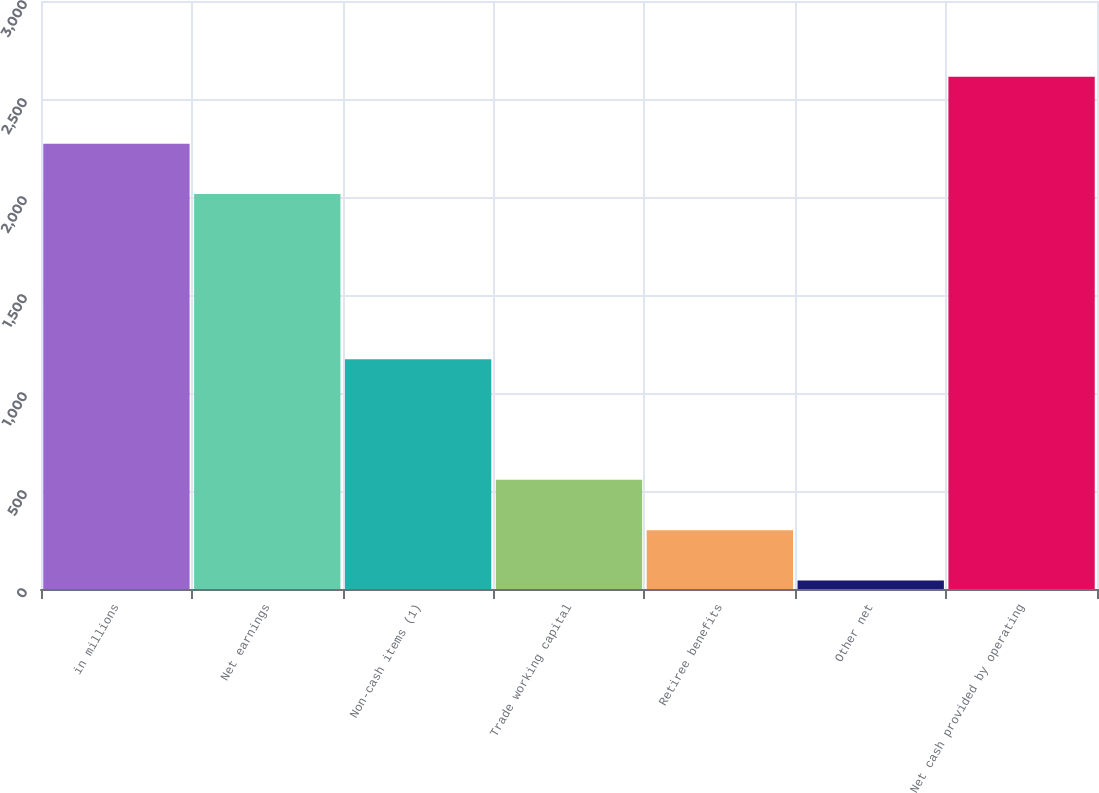Convert chart to OTSL. <chart><loc_0><loc_0><loc_500><loc_500><bar_chart><fcel>in millions<fcel>Net earnings<fcel>Non-cash items (1)<fcel>Trade working capital<fcel>Retiree benefits<fcel>Other net<fcel>Net cash provided by operating<nl><fcel>2272<fcel>2015<fcel>1172<fcel>557<fcel>300<fcel>43<fcel>2613<nl></chart> 